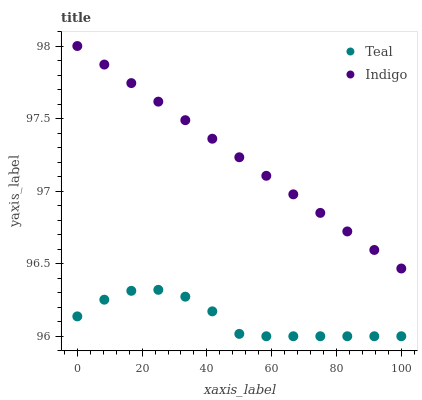Does Teal have the minimum area under the curve?
Answer yes or no. Yes. Does Indigo have the maximum area under the curve?
Answer yes or no. Yes. Does Teal have the maximum area under the curve?
Answer yes or no. No. Is Indigo the smoothest?
Answer yes or no. Yes. Is Teal the roughest?
Answer yes or no. Yes. Is Teal the smoothest?
Answer yes or no. No. Does Teal have the lowest value?
Answer yes or no. Yes. Does Indigo have the highest value?
Answer yes or no. Yes. Does Teal have the highest value?
Answer yes or no. No. Is Teal less than Indigo?
Answer yes or no. Yes. Is Indigo greater than Teal?
Answer yes or no. Yes. Does Teal intersect Indigo?
Answer yes or no. No. 